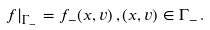<formula> <loc_0><loc_0><loc_500><loc_500>f | _ { \Gamma _ { - } } = f _ { - } ( x , v ) \, , ( x , v ) \in \Gamma _ { - } \, .</formula> 